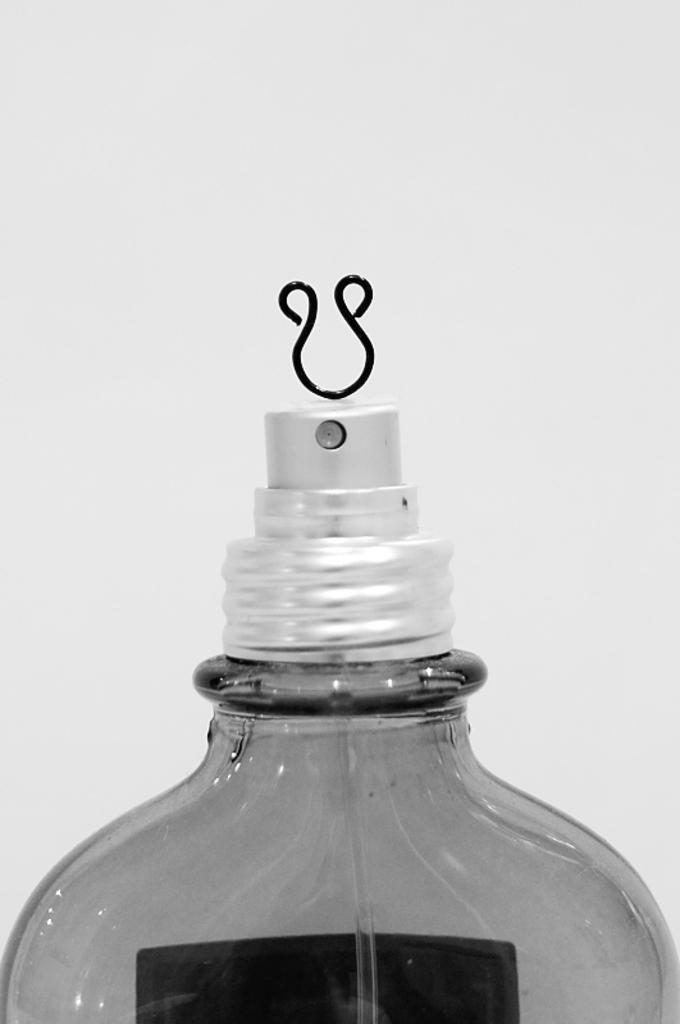How would you summarize this image in a sentence or two? Here in this picture we can see spray bottle present over a place and at the top of it we can see a pin present. 